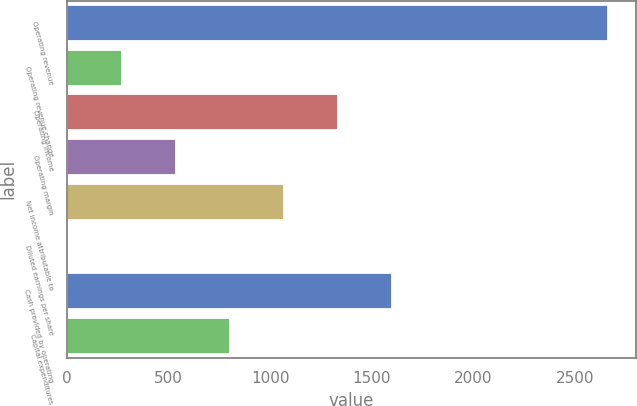Convert chart to OTSL. <chart><loc_0><loc_0><loc_500><loc_500><bar_chart><fcel>Operating revenue<fcel>Operating revenue change<fcel>Operating income<fcel>Operating margin<fcel>Net income attributable to<fcel>Diluted earnings per share<fcel>Cash provided by operating<fcel>Capital expenditures<nl><fcel>2663.6<fcel>269.56<fcel>1333.59<fcel>535.57<fcel>1067.59<fcel>3.55<fcel>1599.59<fcel>801.58<nl></chart> 